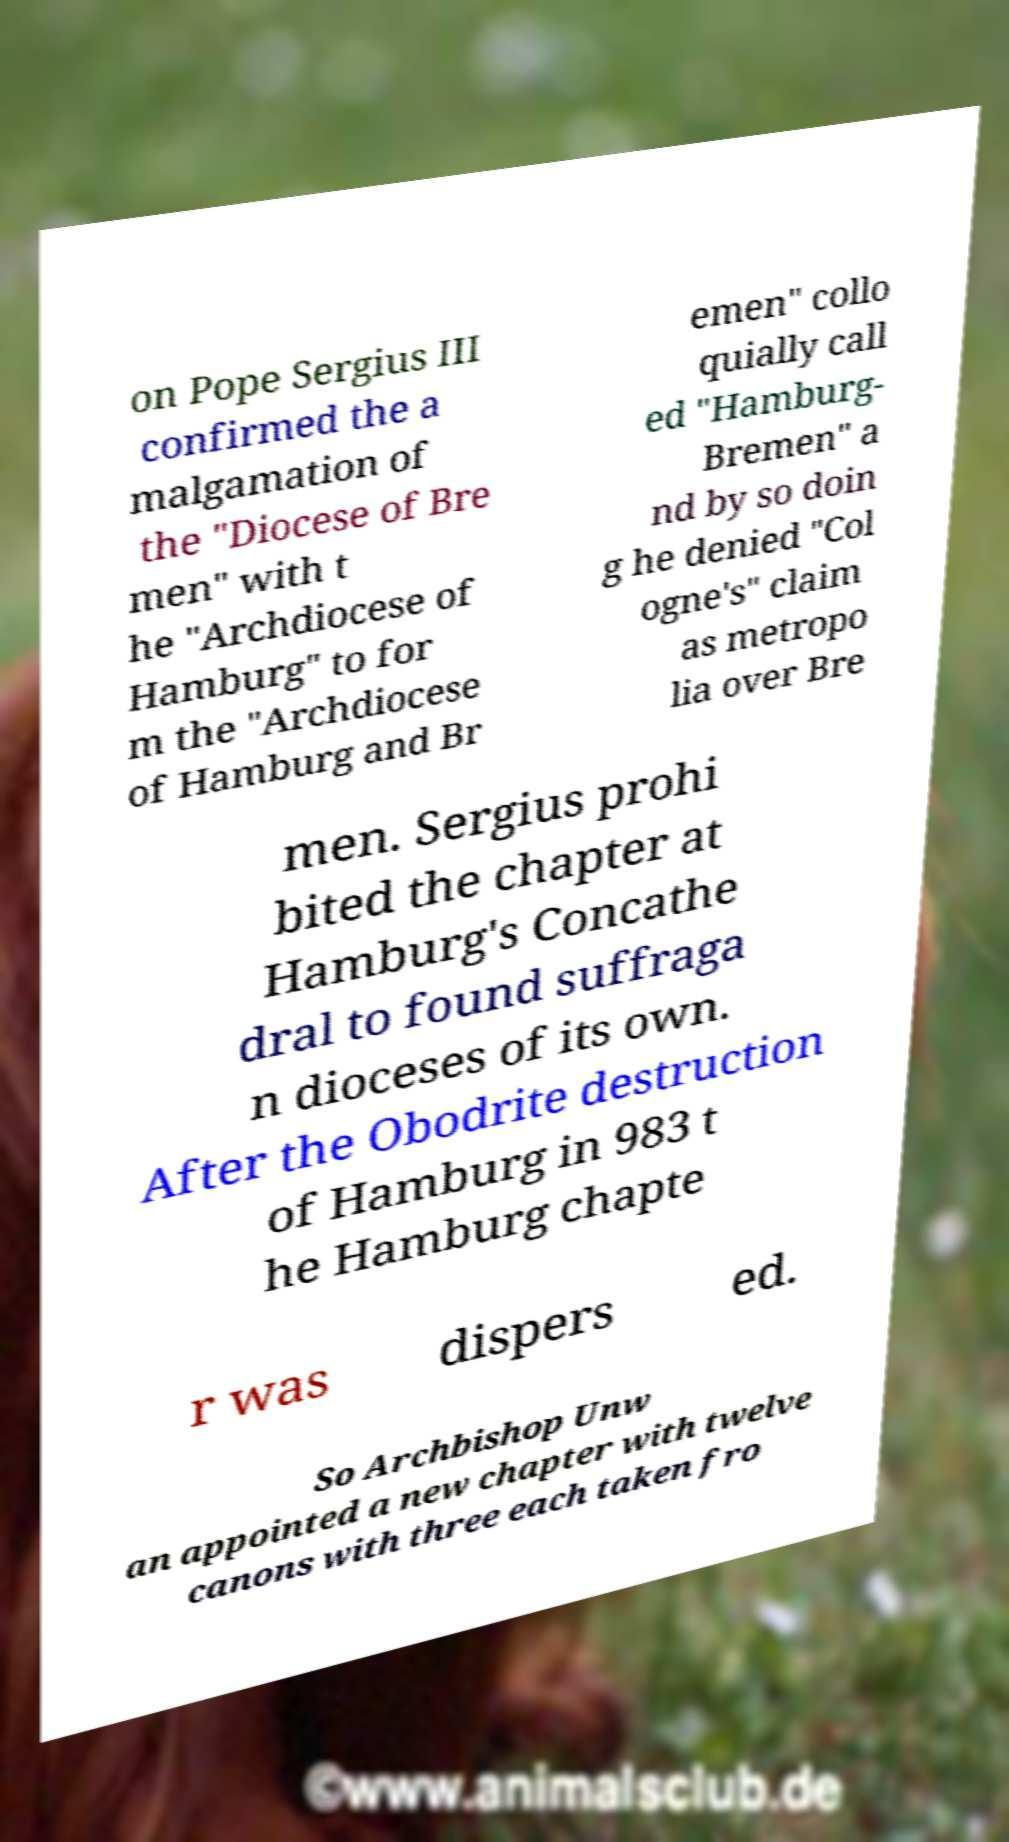I need the written content from this picture converted into text. Can you do that? on Pope Sergius III confirmed the a malgamation of the "Diocese of Bre men" with t he "Archdiocese of Hamburg" to for m the "Archdiocese of Hamburg and Br emen" collo quially call ed "Hamburg- Bremen" a nd by so doin g he denied "Col ogne's" claim as metropo lia over Bre men. Sergius prohi bited the chapter at Hamburg's Concathe dral to found suffraga n dioceses of its own. After the Obodrite destruction of Hamburg in 983 t he Hamburg chapte r was dispers ed. So Archbishop Unw an appointed a new chapter with twelve canons with three each taken fro 